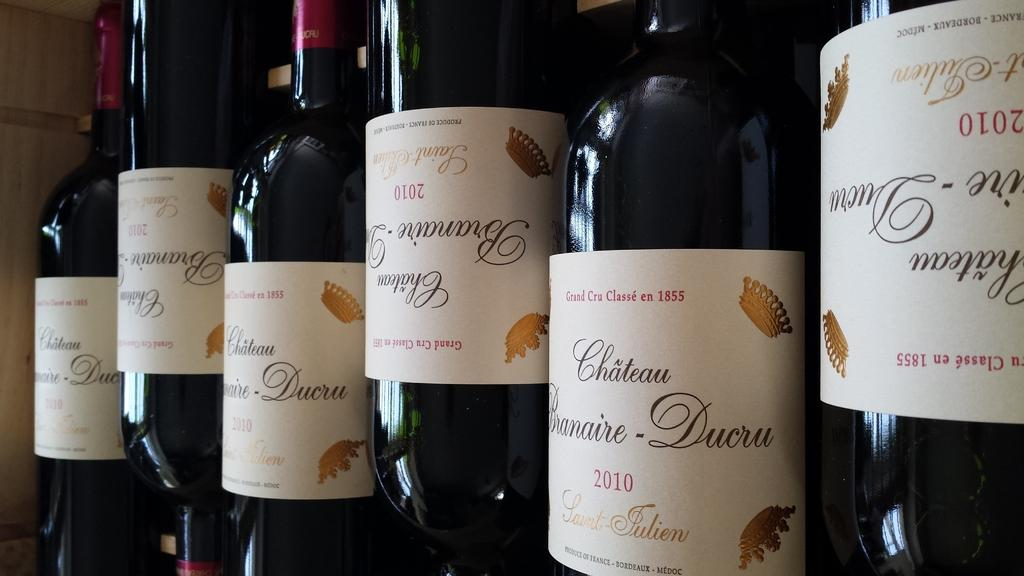Provide a one-sentence caption for the provided image. Wine bottles with red letters stating, "Grand Cru Classe en 1855" at the top of the labels. 